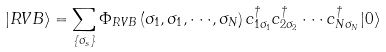Convert formula to latex. <formula><loc_0><loc_0><loc_500><loc_500>| R V B \rangle = \sum _ { \{ \sigma _ { s } \} } \Phi _ { R V B } \left ( \sigma _ { 1 } , \sigma _ { 1 } , \cdot \cdot \cdot , \sigma _ { N } \right ) c _ { 1 \sigma _ { 1 } } ^ { \dagger } c _ { 2 \sigma _ { 2 } } ^ { \dagger } \cdot \cdot \cdot c _ { N \sigma _ { N } } ^ { \dagger } | 0 \rangle</formula> 